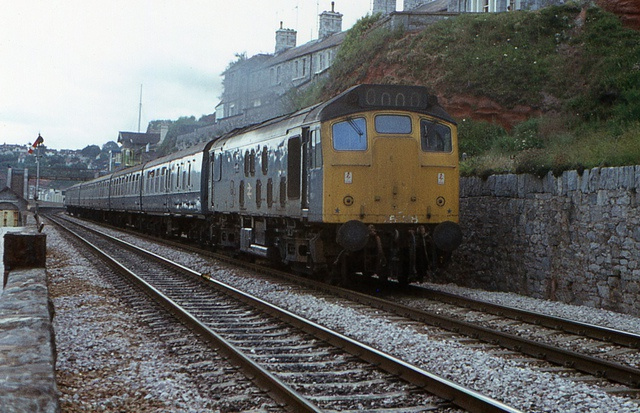Describe the objects in this image and their specific colors. I can see a train in white, black, gray, and olive tones in this image. 